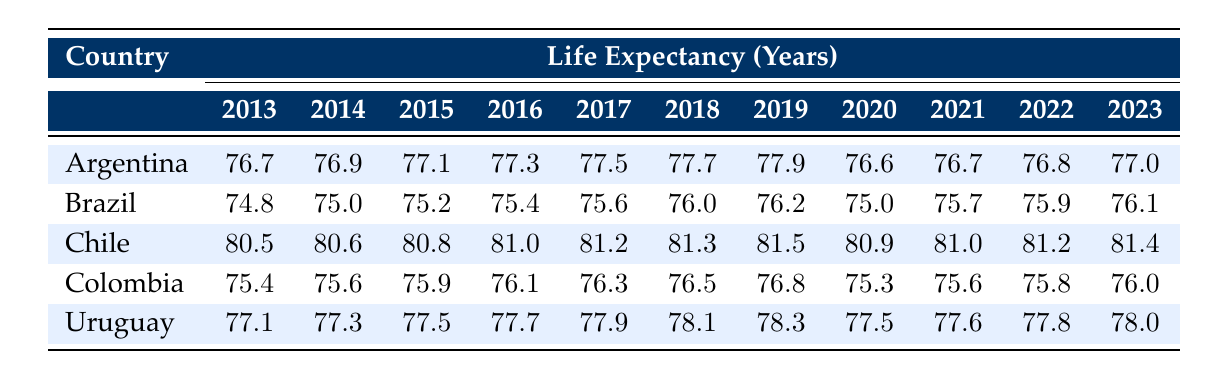What was the life expectancy of Chile in 2020? In the row for Chile, I check the column for the year 2020, which shows a value of 80.9.
Answer: 80.9 Which country had the highest life expectancy in 2019? In 2019, I compare the values for each country: Argentina with 77.9, Brazil with 76.2, Chile with 81.5, Colombia with 76.8, and Uruguay with 78.3. Chile has the highest value at 81.5.
Answer: Chile What is the difference in life expectancy between Brazil in 2013 and Brazil in 2023? I find Brazil's life expectancy in 2013, which is 74.8, and in 2023, which is 76.1. The difference is 76.1 - 74.8 = 1.3 years.
Answer: 1.3 Was there a decline in life expectancy for Argentina from 2019 to 2020? In 2019, Argentina's life expectancy is 77.9, and in 2020, it drops to 76.6. This is a decrease, indicating a decline.
Answer: Yes What is the average life expectancy of Uruguay over the decade from 2013 to 2023? I add the life expectancy values for Uruguay between 2013 and 2023: (77.1 + 77.3 + 77.5 + 77.7 + 77.9 + 78.1 + 78.3 + 77.5 + 77.6 + 77.8 + 78.0) = 861.6. There are 11 data points, so the average is 861.6 / 11 = 78.3.
Answer: 78.3 How did life expectancy in Colombia in 2022 compare to that of Colombia in 2013? Colombia's life expectancy in 2022 is 75.8, and in 2013 it is 75.4. I find that 75.8 is greater than 75.4, indicating an increase.
Answer: Yes What trend can be observed in the life expectancy of Argentina from 2013 to 2023? I look at the life expectancy values for Argentina each year: It rises steadily from 76.7 in 2013 to a peak of 77.9 in 2019, then it decreases to 76.6 in 2020, and finally increases again to 77.0 in 2023. The overall trend shows fluctuations but a slight increase overall since 2013.
Answer: Fluctuating trend with a slight increase Which country consistently had the lowest life expectancy over the past decade? I compare the lowest life expectancy values among countries for each year. Brazil starts the decade at 74.8, which remains lower than all other countries throughout the years, even in 2023 when it reaches 76.1.
Answer: Brazil 